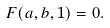<formula> <loc_0><loc_0><loc_500><loc_500>F ( a , b , 1 ) = 0 .</formula> 